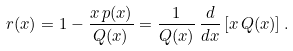Convert formula to latex. <formula><loc_0><loc_0><loc_500><loc_500>r ( x ) = 1 - \frac { x \, p ( x ) } { Q ( x ) } = \frac { 1 } { Q ( x ) } \, \frac { d } { d x } \left [ x \, Q ( x ) \right ] .</formula> 